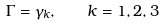<formula> <loc_0><loc_0><loc_500><loc_500>\Gamma = \gamma _ { k } , \quad k = 1 , 2 , 3</formula> 